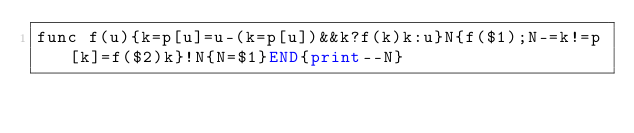<code> <loc_0><loc_0><loc_500><loc_500><_Awk_>func f(u){k=p[u]=u-(k=p[u])&&k?f(k)k:u}N{f($1);N-=k!=p[k]=f($2)k}!N{N=$1}END{print--N}</code> 